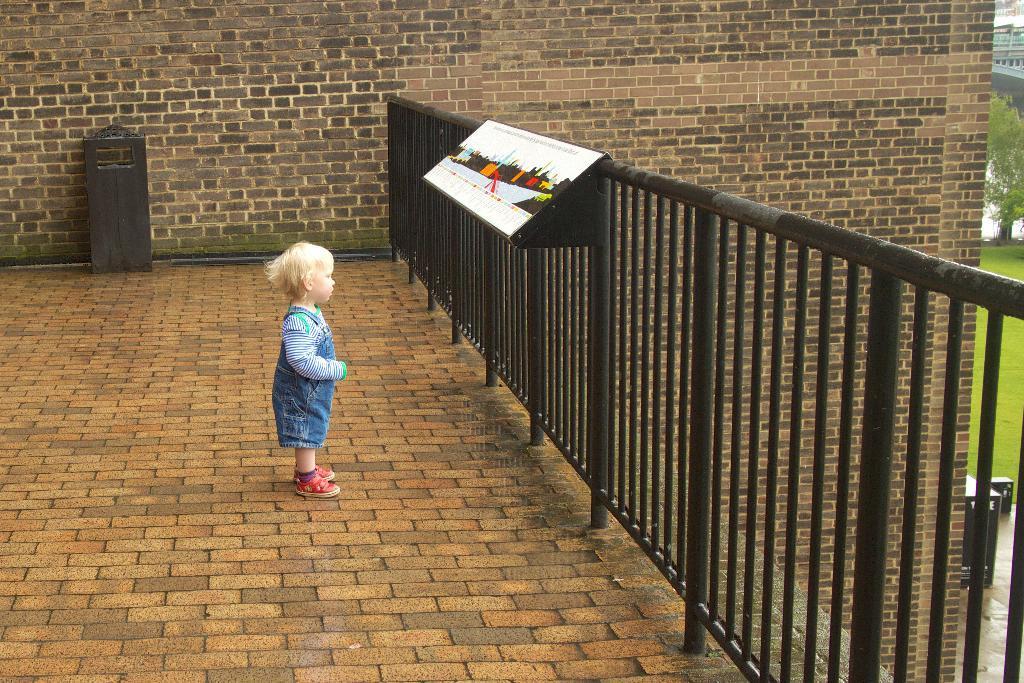Can you describe this image briefly? A kid is standing on the floor at the fence and there is an object on the fence. In the background there is an object at the wall. On the right we can see a bridge,water,tree,grass and two objects on the ground floor. 